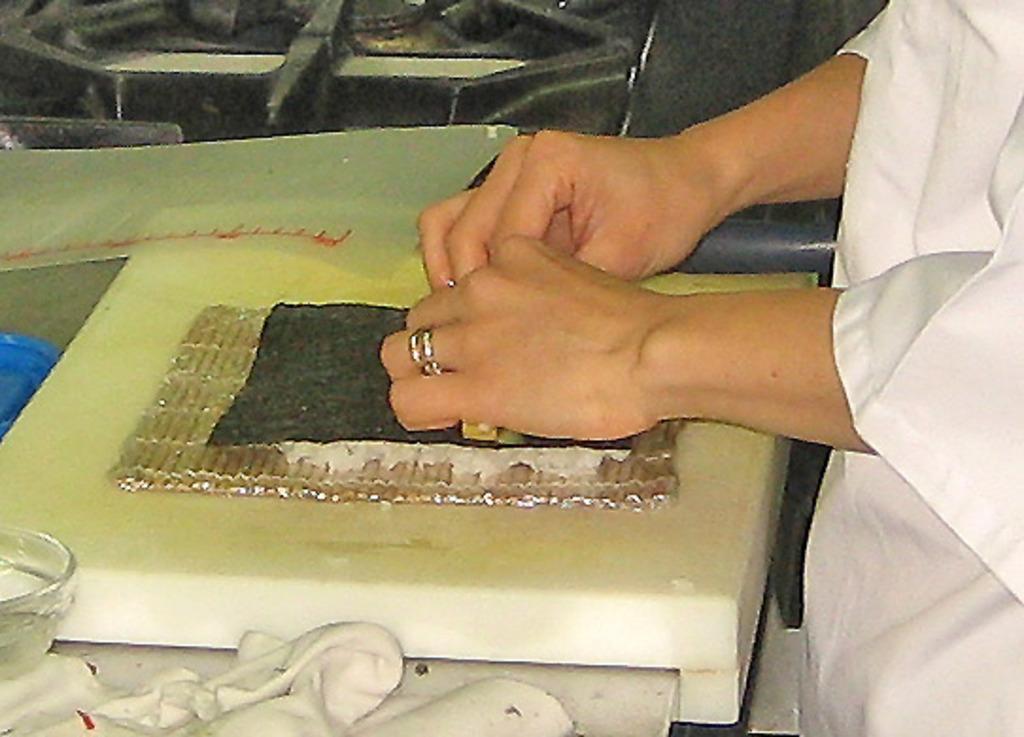Please provide a concise description of this image. In the picture I can see a person is standing and wearing white color clothes. I can also see a glass bowl and some other objects. 